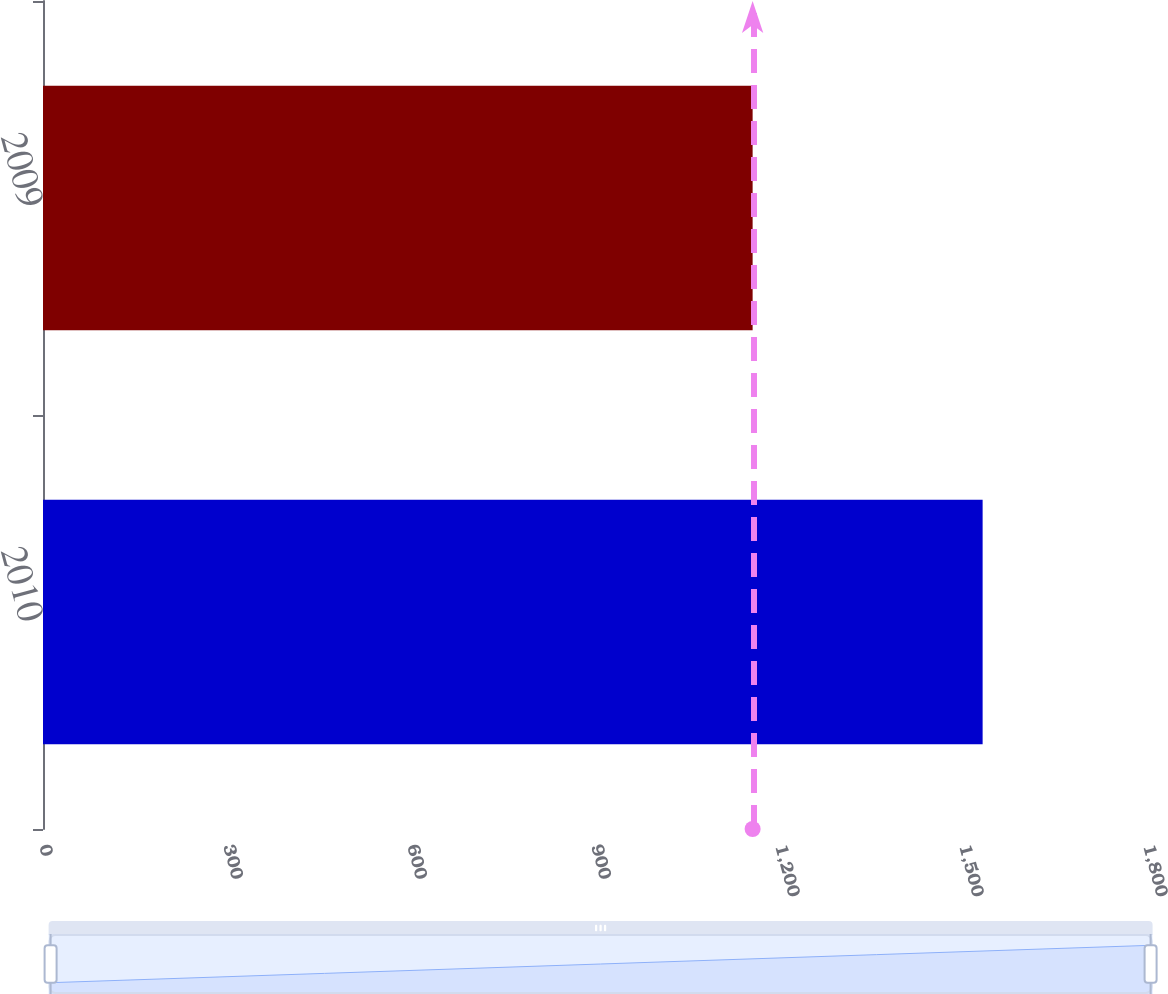Convert chart to OTSL. <chart><loc_0><loc_0><loc_500><loc_500><bar_chart><fcel>2010<fcel>2009<nl><fcel>1532<fcel>1157<nl></chart> 